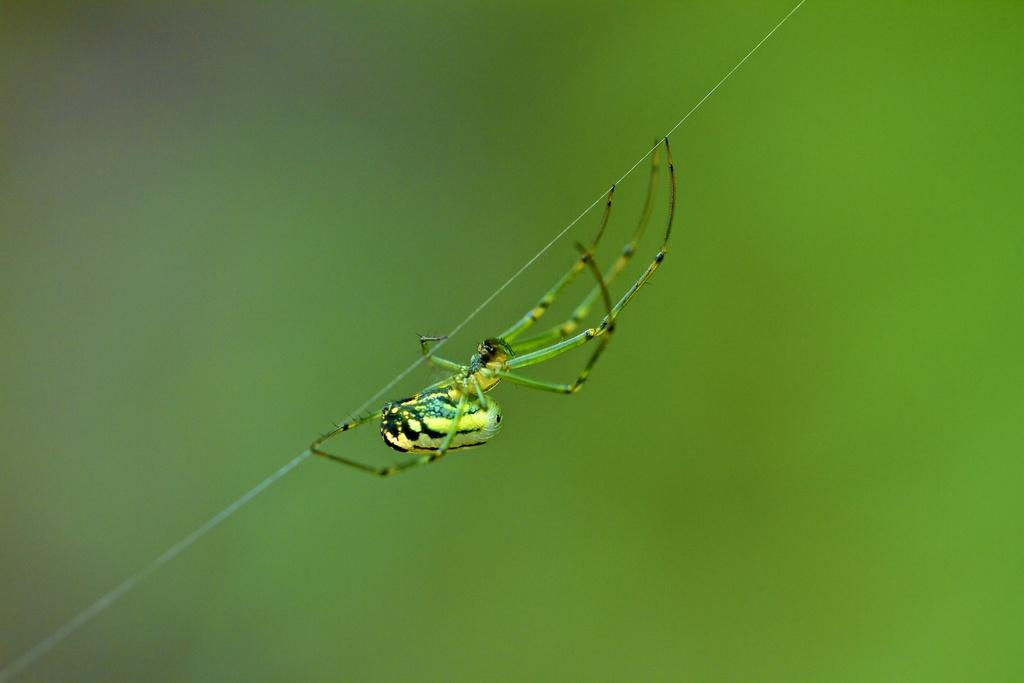What is present in the image that indicates the presence of a spider? There is a spider web in the image, and a spider is on the web. What colors can be seen on the spider? The spider has yellow, green, and black coloration. What is the color of the background in the image? The background of the image is green. Can you see a ghost interacting with the spider in the image? No, there is no ghost present in the image. What type of appliance is visible in the image? There is no appliance present in the image; it features a spider and its web. 